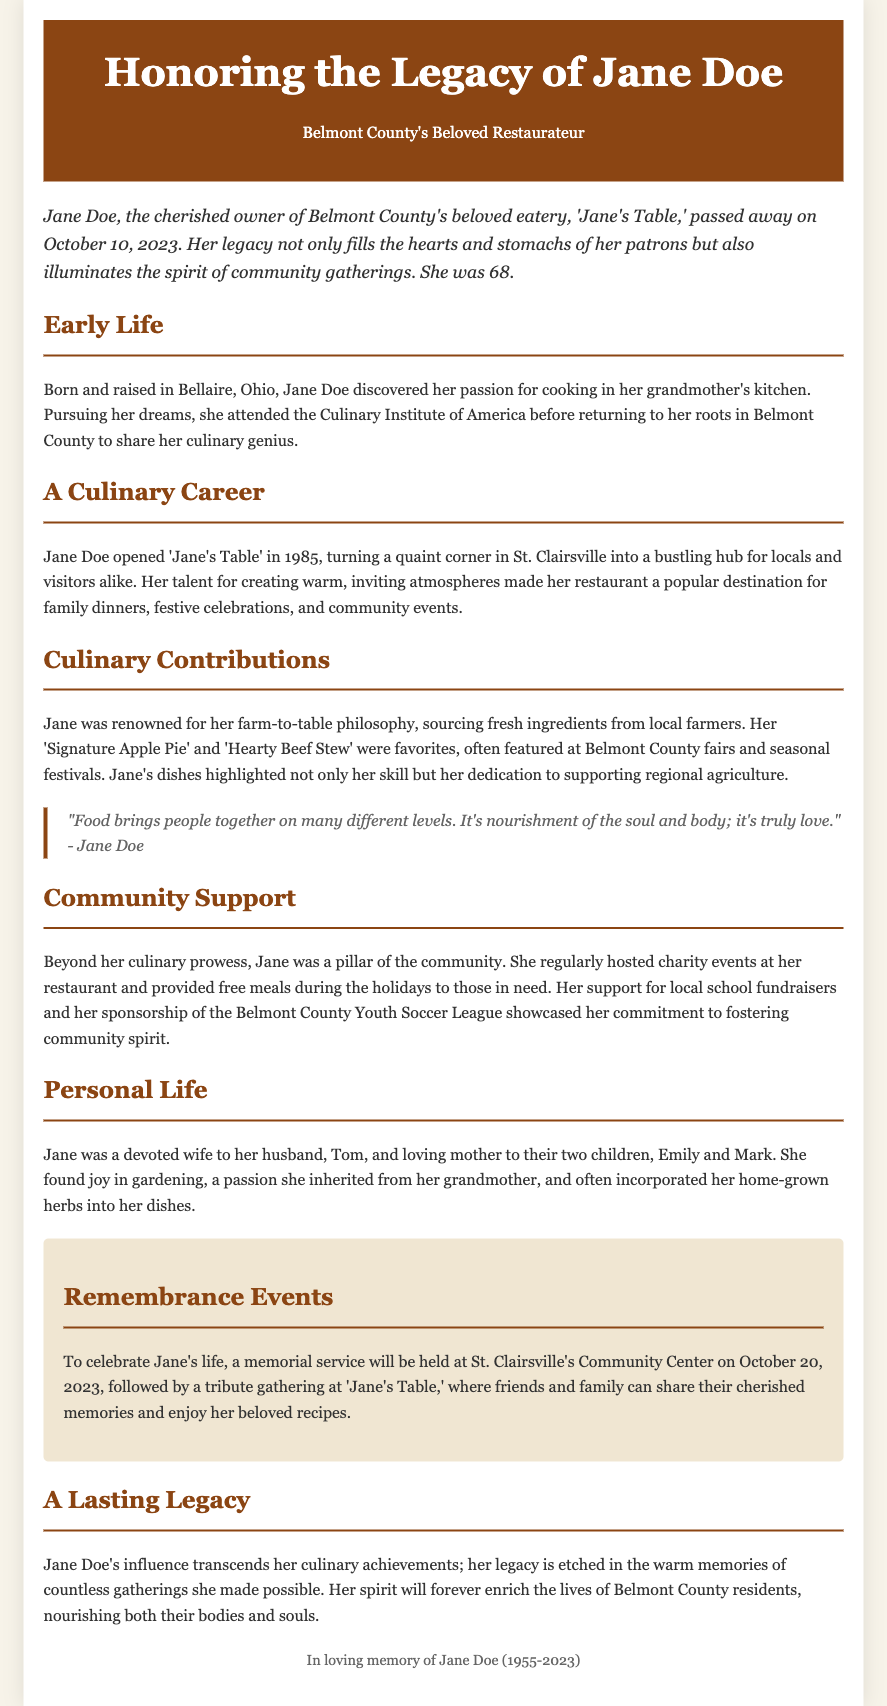What was the name of Jane Doe's restaurant? The document mentions that Jane Doe was the owner of 'Jane's Table.'
Answer: Jane's Table When did Jane Doe pass away? The obituary states that Jane Doe passed away on October 10, 2023.
Answer: October 10, 2023 In what year did Jane open her restaurant? The document indicates that Jane opened 'Jane's Table' in 1985.
Answer: 1985 What is Jane's renowned farm-to-table dish mentioned? The obituary highlights the 'Signature Apple Pie' as one of Jane's renowned dishes.
Answer: Signature Apple Pie What kind of events did Jane regularly host at her restaurant? The document references that Jane hosted charity events at her restaurant.
Answer: Charity events What was Jane's age at the time of her passing? The obituary mentions that Jane was 68 years old when she passed away.
Answer: 68 Where will the memorial service be held? The document states that the memorial service will be held at St. Clairsville's Community Center.
Answer: St. Clairsville's Community Center Who are Jane's two children? The obituary lists Emily and Mark as Jane's children.
Answer: Emily and Mark What philosophy did Jane follow regarding food sourcing? The document mentions Jane was renowned for her farm-to-table philosophy.
Answer: Farm-to-table 